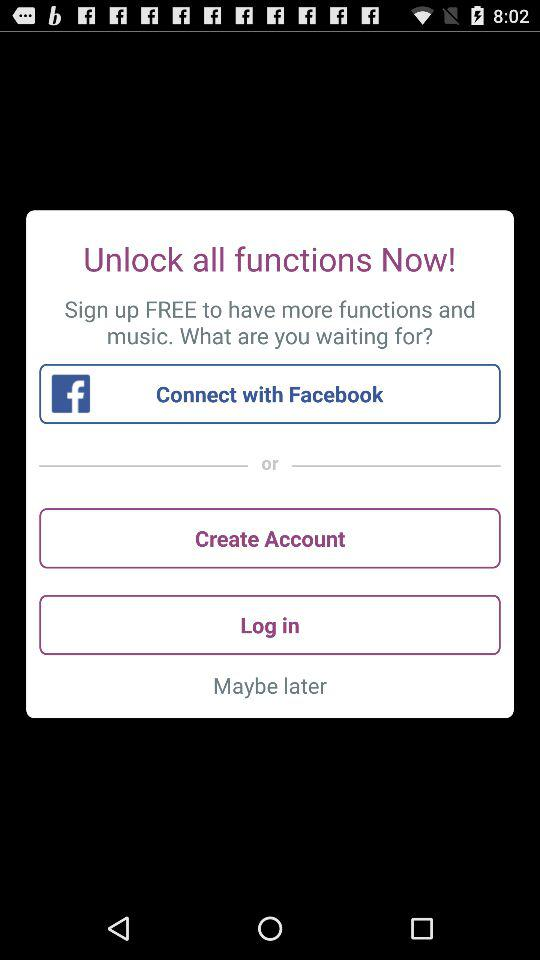Is signing up free or paid? Signing up is free. 